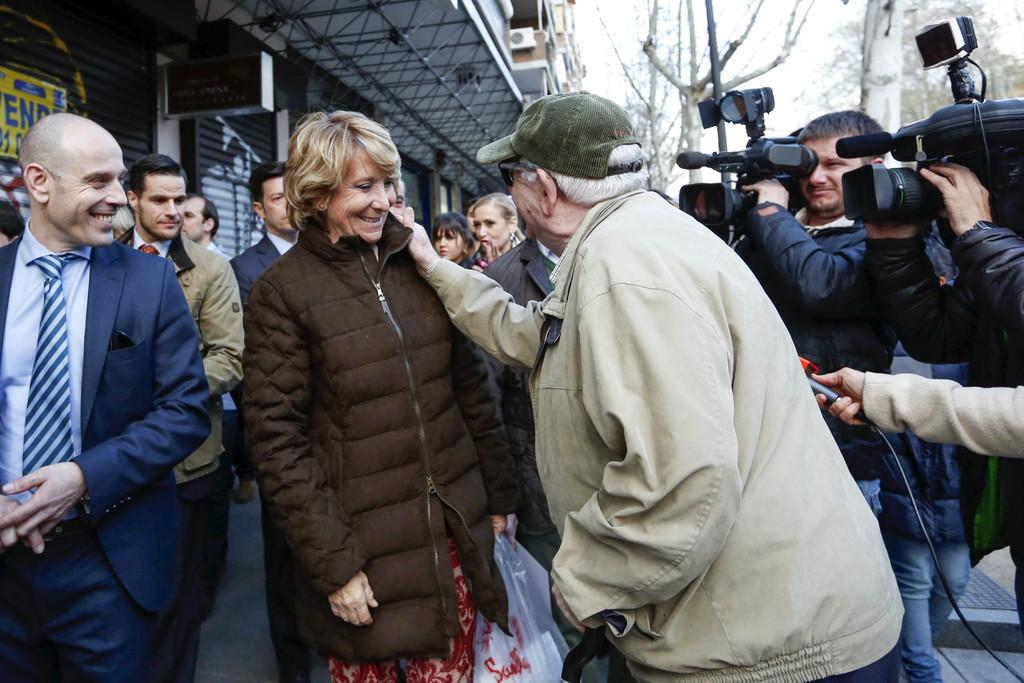How many people are in the image? There are people in the image, but the exact number is not specified. What are two of the people doing in the image? Two persons are holding cameras in the image. What type of structure can be seen in the image? There is a building in the image. What object is present in the image that might be used for displaying information? There is a board in the image. What type of natural vegetation is visible in the image? There are trees in the image. What is visible in the background of the image? The sky is visible in the background of the image. What type of canvas is being used by the person in the image? There is no canvas present in the image. How does the skirt of the person in the image expand when they walk? There is no person wearing a skirt in the image. 